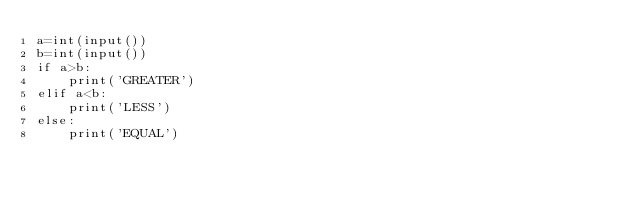<code> <loc_0><loc_0><loc_500><loc_500><_Python_>a=int(input())
b=int(input())
if a>b:
    print('GREATER')
elif a<b:
    print('LESS')
else:
    print('EQUAL')</code> 